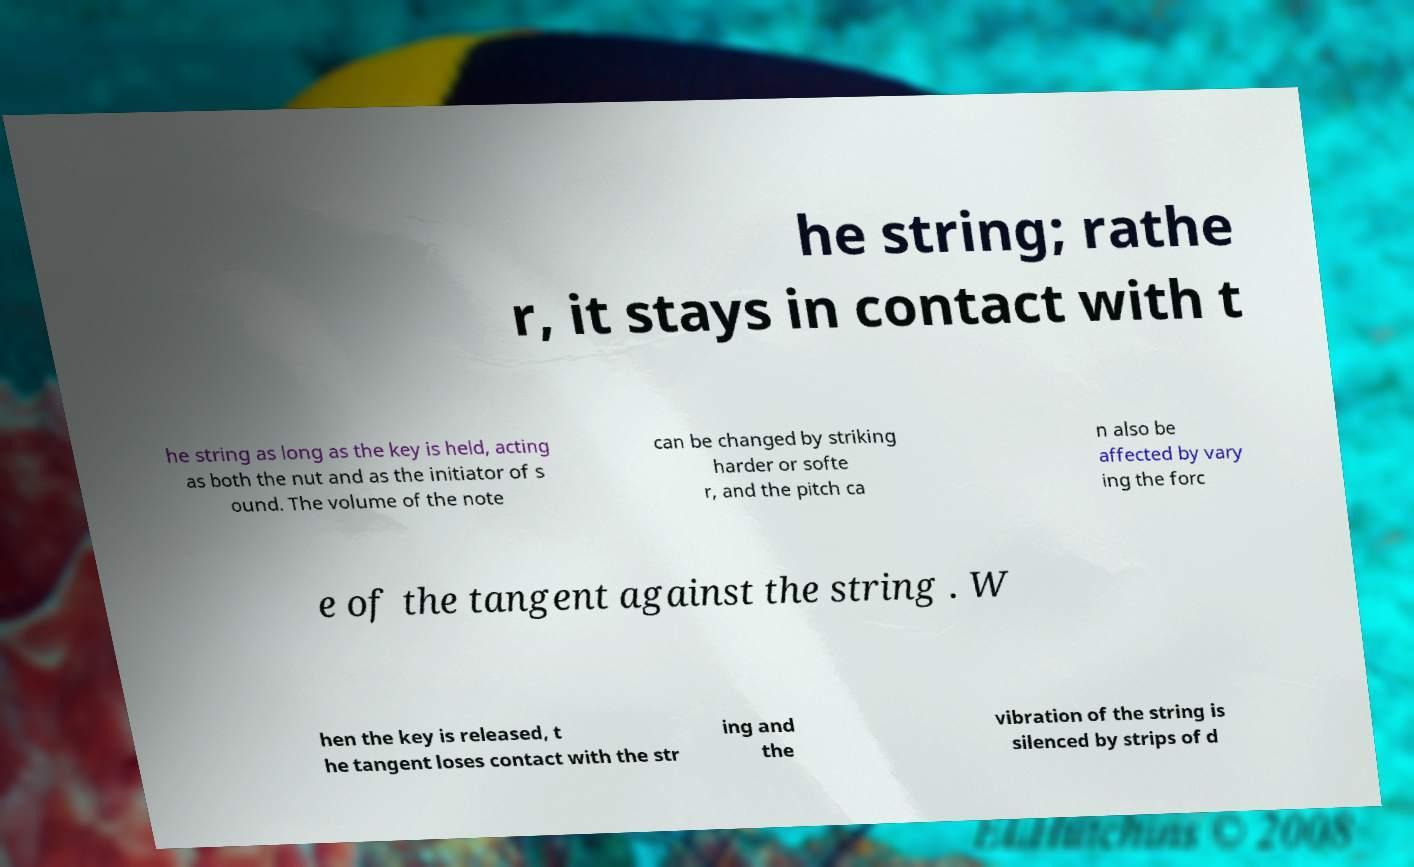Could you extract and type out the text from this image? he string; rathe r, it stays in contact with t he string as long as the key is held, acting as both the nut and as the initiator of s ound. The volume of the note can be changed by striking harder or softe r, and the pitch ca n also be affected by vary ing the forc e of the tangent against the string . W hen the key is released, t he tangent loses contact with the str ing and the vibration of the string is silenced by strips of d 